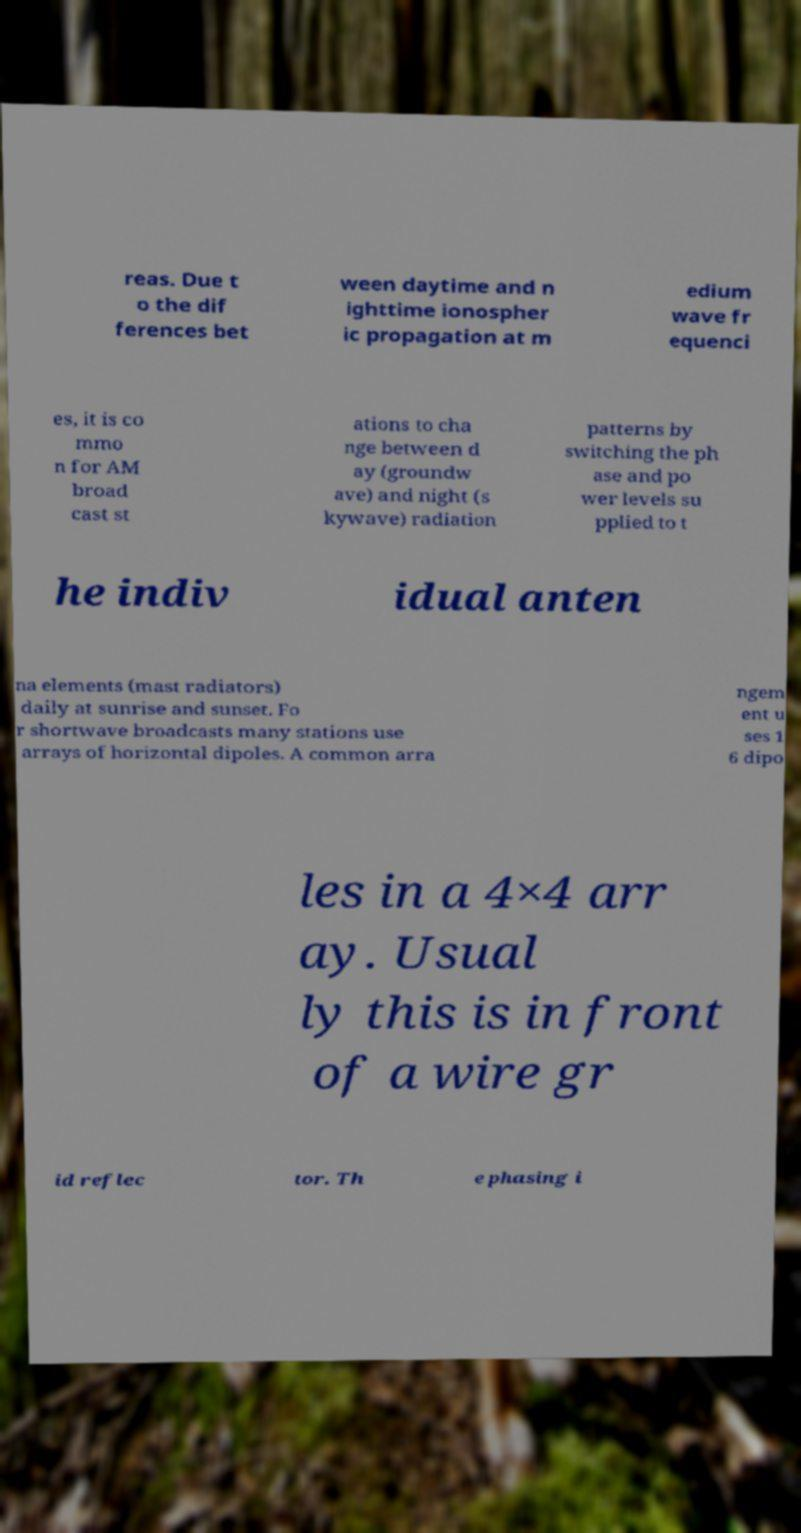For documentation purposes, I need the text within this image transcribed. Could you provide that? reas. Due t o the dif ferences bet ween daytime and n ighttime ionospher ic propagation at m edium wave fr equenci es, it is co mmo n for AM broad cast st ations to cha nge between d ay (groundw ave) and night (s kywave) radiation patterns by switching the ph ase and po wer levels su pplied to t he indiv idual anten na elements (mast radiators) daily at sunrise and sunset. Fo r shortwave broadcasts many stations use arrays of horizontal dipoles. A common arra ngem ent u ses 1 6 dipo les in a 4×4 arr ay. Usual ly this is in front of a wire gr id reflec tor. Th e phasing i 